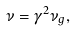<formula> <loc_0><loc_0><loc_500><loc_500>\nu = \gamma ^ { 2 } \nu _ { g } ,</formula> 